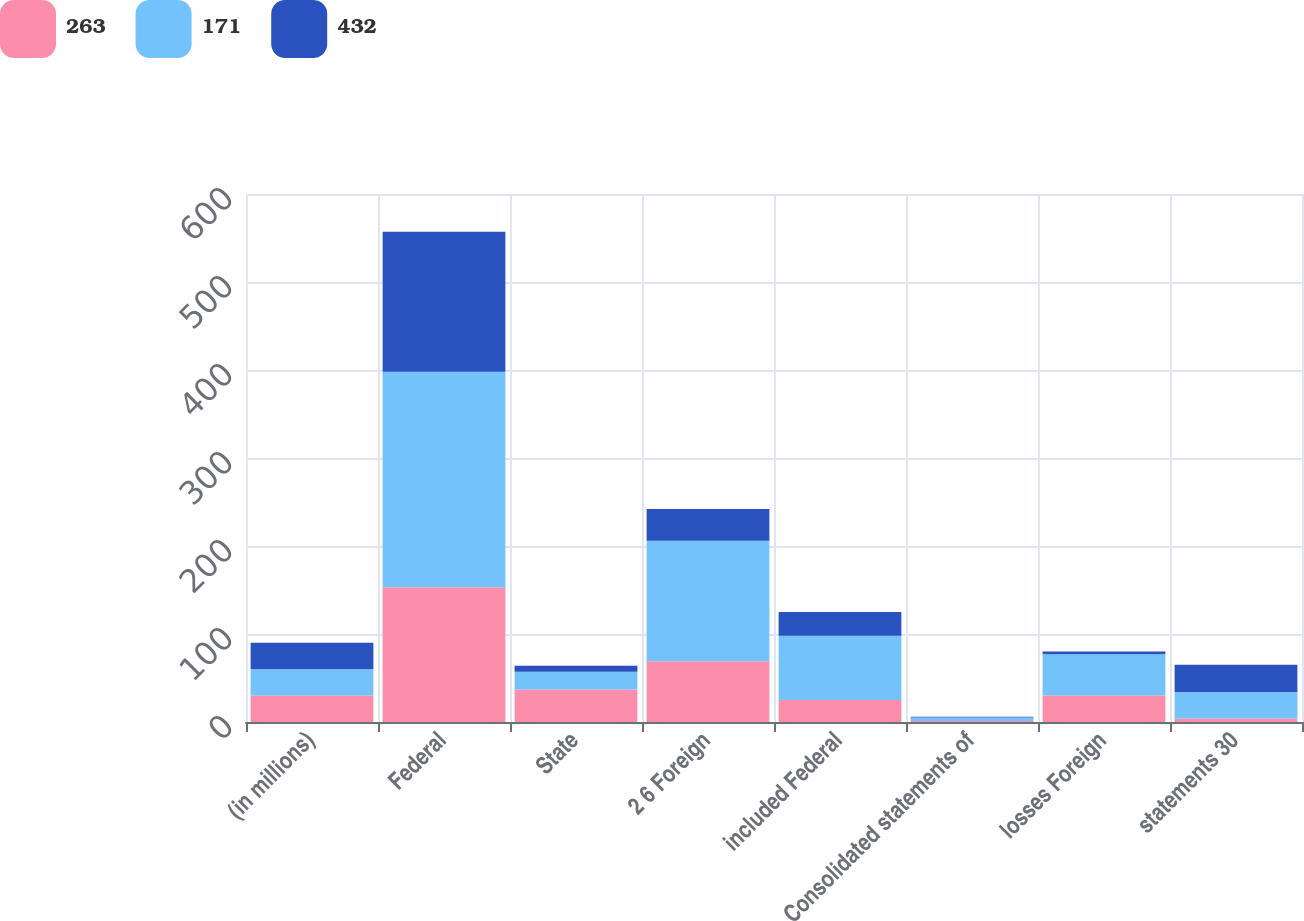Convert chart. <chart><loc_0><loc_0><loc_500><loc_500><stacked_bar_chart><ecel><fcel>(in millions)<fcel>Federal<fcel>State<fcel>2 6 Foreign<fcel>included Federal<fcel>Consolidated statements of<fcel>losses Foreign<fcel>statements 30<nl><fcel>263<fcel>30<fcel>153<fcel>37<fcel>69<fcel>25<fcel>1<fcel>30<fcel>4<nl><fcel>171<fcel>30<fcel>245<fcel>20<fcel>137<fcel>73<fcel>4<fcel>47<fcel>30<nl><fcel>432<fcel>30<fcel>159<fcel>7<fcel>36<fcel>27<fcel>1<fcel>3<fcel>31<nl></chart> 